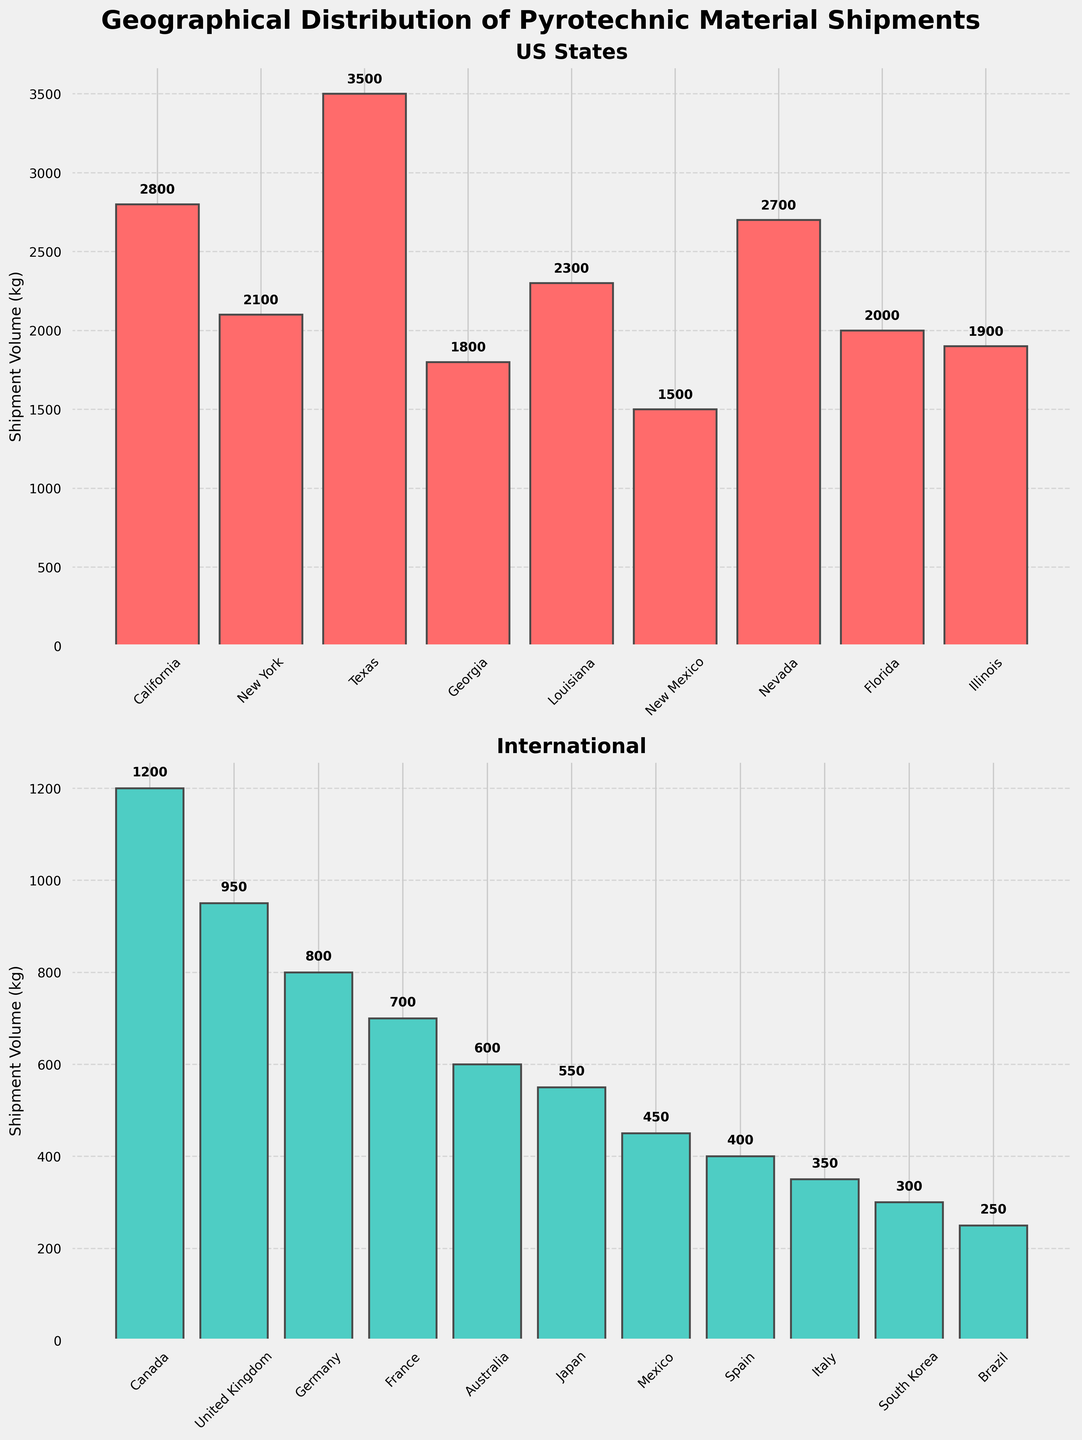What's the title of the plot? The title of the plot is displayed at the top and reads "Geographical Distribution of Pyrotechnic Material Shipments."
Answer: Geographical Distribution of Pyrotechnic Material Shipments How many categories are there in the US States subplot? The US States subplot includes the following categories: California, New York, Texas, Georgia, Louisiana, New Mexico, Nevada, Florida, and Illinois, which sums up to 9 categories.
Answer: 9 Which international location has the highest shipment volume? By examining the heights of the bars in the International subplot, Canada has the tallest bar, indicating the highest shipment volume.
Answer: Canada What is the total shipment volume for the US States? To find the total shipment volume, add the shipment volumes for California (2800 kg), New York (2100 kg), Texas (3500 kg), Georgia (1800 kg), Louisiana (2300 kg), New Mexico (1500 kg), Nevada (2700 kg), Florida (2000 kg), and Illinois (1900 kg). The total is 2800 + 2100 + 3500 + 1800 + 2300 + 1500 + 2700 + 2000 + 1900 = 20600 kg.
Answer: 20600 kg Which US State has the lowest shipment volume, and what is the volume? In the US States subplot, New Mexico has the lowest bar among the states, representing 1500 kg.
Answer: New Mexico, 1500 kg How does the shipment volume in California compare to that in Texas? In the US States subplot, the bar for Texas is taller than the bar for California. The shipment volume in Texas is 3500 kg, whereas it is 2800 kg in California.
Answer: Texas has a higher shipment volume than California What is the shipment volume difference between the United Kingdom and Japan? The shipment volume for the United Kingdom is 950 kg, and for Japan, it is 550 kg. The difference is calculated by subtracting Japan's volume from the United Kingdom's volume: 950 kg - 550 kg = 400 kg.
Answer: 400 kg What are the two international locations with the smallest shipment volumes? In the International subplot, Brazil and South Korea have the smallest shipment volumes, indicated by the shortest bars which are labeled with 250 kg and 300 kg, respectively.
Answer: Brazil and South Korea What's the range of the shipment volumes for US States? The range of shipment volumes can be found by subtracting the smallest volume (New Mexico, 1500 kg) from the largest volume (Texas, 3500 kg): 3500 kg - 1500 kg = 2000 kg.
Answer: 2000 kg 